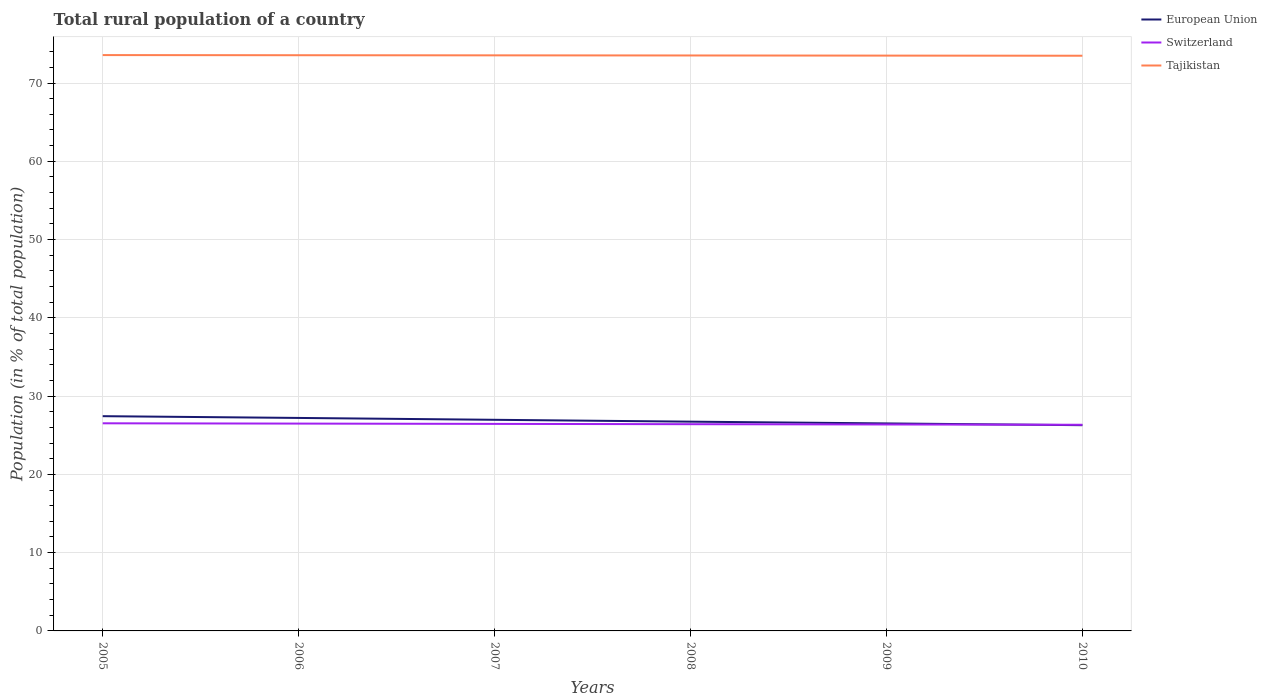How many different coloured lines are there?
Offer a terse response. 3. Does the line corresponding to Switzerland intersect with the line corresponding to Tajikistan?
Provide a short and direct response. No. Across all years, what is the maximum rural population in Switzerland?
Make the answer very short. 26.34. What is the total rural population in Tajikistan in the graph?
Your answer should be very brief. 0.02. What is the difference between the highest and the second highest rural population in Tajikistan?
Give a very brief answer. 0.08. Is the rural population in Tajikistan strictly greater than the rural population in European Union over the years?
Provide a succinct answer. No. How many lines are there?
Your answer should be compact. 3. How many years are there in the graph?
Keep it short and to the point. 6. What is the difference between two consecutive major ticks on the Y-axis?
Provide a succinct answer. 10. Does the graph contain any zero values?
Give a very brief answer. No. Does the graph contain grids?
Your answer should be very brief. Yes. What is the title of the graph?
Give a very brief answer. Total rural population of a country. What is the label or title of the X-axis?
Provide a succinct answer. Years. What is the label or title of the Y-axis?
Ensure brevity in your answer.  Population (in % of total population). What is the Population (in % of total population) in European Union in 2005?
Your answer should be compact. 27.43. What is the Population (in % of total population) in Switzerland in 2005?
Provide a short and direct response. 26.53. What is the Population (in % of total population) in Tajikistan in 2005?
Your response must be concise. 73.57. What is the Population (in % of total population) of European Union in 2006?
Keep it short and to the point. 27.21. What is the Population (in % of total population) in Switzerland in 2006?
Give a very brief answer. 26.49. What is the Population (in % of total population) of Tajikistan in 2006?
Provide a short and direct response. 73.55. What is the Population (in % of total population) of European Union in 2007?
Offer a very short reply. 26.97. What is the Population (in % of total population) of Switzerland in 2007?
Your answer should be very brief. 26.45. What is the Population (in % of total population) in Tajikistan in 2007?
Ensure brevity in your answer.  73.53. What is the Population (in % of total population) of European Union in 2008?
Your answer should be very brief. 26.74. What is the Population (in % of total population) in Switzerland in 2008?
Make the answer very short. 26.41. What is the Population (in % of total population) in Tajikistan in 2008?
Ensure brevity in your answer.  73.52. What is the Population (in % of total population) in European Union in 2009?
Offer a terse response. 26.51. What is the Population (in % of total population) in Switzerland in 2009?
Provide a succinct answer. 26.38. What is the Population (in % of total population) in Tajikistan in 2009?
Make the answer very short. 73.5. What is the Population (in % of total population) of European Union in 2010?
Offer a very short reply. 26.28. What is the Population (in % of total population) of Switzerland in 2010?
Provide a short and direct response. 26.34. What is the Population (in % of total population) of Tajikistan in 2010?
Make the answer very short. 73.48. Across all years, what is the maximum Population (in % of total population) of European Union?
Your answer should be very brief. 27.43. Across all years, what is the maximum Population (in % of total population) of Switzerland?
Keep it short and to the point. 26.53. Across all years, what is the maximum Population (in % of total population) of Tajikistan?
Provide a short and direct response. 73.57. Across all years, what is the minimum Population (in % of total population) in European Union?
Give a very brief answer. 26.28. Across all years, what is the minimum Population (in % of total population) of Switzerland?
Your response must be concise. 26.34. Across all years, what is the minimum Population (in % of total population) of Tajikistan?
Keep it short and to the point. 73.48. What is the total Population (in % of total population) in European Union in the graph?
Provide a succinct answer. 161.15. What is the total Population (in % of total population) in Switzerland in the graph?
Your answer should be very brief. 158.59. What is the total Population (in % of total population) of Tajikistan in the graph?
Keep it short and to the point. 441.15. What is the difference between the Population (in % of total population) of European Union in 2005 and that in 2006?
Your response must be concise. 0.22. What is the difference between the Population (in % of total population) of Switzerland in 2005 and that in 2006?
Offer a terse response. 0.04. What is the difference between the Population (in % of total population) of Tajikistan in 2005 and that in 2006?
Keep it short and to the point. 0.02. What is the difference between the Population (in % of total population) of European Union in 2005 and that in 2007?
Keep it short and to the point. 0.46. What is the difference between the Population (in % of total population) of Switzerland in 2005 and that in 2007?
Keep it short and to the point. 0.08. What is the difference between the Population (in % of total population) in Tajikistan in 2005 and that in 2007?
Provide a succinct answer. 0.03. What is the difference between the Population (in % of total population) of European Union in 2005 and that in 2008?
Offer a terse response. 0.7. What is the difference between the Population (in % of total population) of Switzerland in 2005 and that in 2008?
Your answer should be very brief. 0.11. What is the difference between the Population (in % of total population) in Tajikistan in 2005 and that in 2008?
Your response must be concise. 0.05. What is the difference between the Population (in % of total population) in European Union in 2005 and that in 2009?
Provide a succinct answer. 0.92. What is the difference between the Population (in % of total population) of Switzerland in 2005 and that in 2009?
Provide a succinct answer. 0.15. What is the difference between the Population (in % of total population) of Tajikistan in 2005 and that in 2009?
Your response must be concise. 0.07. What is the difference between the Population (in % of total population) in European Union in 2005 and that in 2010?
Keep it short and to the point. 1.15. What is the difference between the Population (in % of total population) in Switzerland in 2005 and that in 2010?
Offer a very short reply. 0.19. What is the difference between the Population (in % of total population) in Tajikistan in 2005 and that in 2010?
Your response must be concise. 0.08. What is the difference between the Population (in % of total population) of European Union in 2006 and that in 2007?
Provide a short and direct response. 0.24. What is the difference between the Population (in % of total population) in Switzerland in 2006 and that in 2007?
Provide a succinct answer. 0.04. What is the difference between the Population (in % of total population) in Tajikistan in 2006 and that in 2007?
Keep it short and to the point. 0.02. What is the difference between the Population (in % of total population) in European Union in 2006 and that in 2008?
Keep it short and to the point. 0.48. What is the difference between the Population (in % of total population) in Switzerland in 2006 and that in 2008?
Give a very brief answer. 0.08. What is the difference between the Population (in % of total population) in Tajikistan in 2006 and that in 2008?
Provide a short and direct response. 0.03. What is the difference between the Population (in % of total population) of European Union in 2006 and that in 2009?
Give a very brief answer. 0.7. What is the difference between the Population (in % of total population) of Switzerland in 2006 and that in 2009?
Give a very brief answer. 0.11. What is the difference between the Population (in % of total population) in European Union in 2006 and that in 2010?
Your response must be concise. 0.93. What is the difference between the Population (in % of total population) of Switzerland in 2006 and that in 2010?
Provide a succinct answer. 0.15. What is the difference between the Population (in % of total population) of Tajikistan in 2006 and that in 2010?
Offer a terse response. 0.07. What is the difference between the Population (in % of total population) in European Union in 2007 and that in 2008?
Ensure brevity in your answer.  0.24. What is the difference between the Population (in % of total population) in Switzerland in 2007 and that in 2008?
Offer a terse response. 0.04. What is the difference between the Population (in % of total population) of Tajikistan in 2007 and that in 2008?
Your answer should be very brief. 0.02. What is the difference between the Population (in % of total population) in European Union in 2007 and that in 2009?
Your answer should be compact. 0.46. What is the difference between the Population (in % of total population) of Switzerland in 2007 and that in 2009?
Make the answer very short. 0.07. What is the difference between the Population (in % of total population) in Tajikistan in 2007 and that in 2009?
Your answer should be compact. 0.03. What is the difference between the Population (in % of total population) of European Union in 2007 and that in 2010?
Make the answer very short. 0.69. What is the difference between the Population (in % of total population) of Switzerland in 2007 and that in 2010?
Offer a terse response. 0.11. What is the difference between the Population (in % of total population) in Tajikistan in 2007 and that in 2010?
Offer a very short reply. 0.05. What is the difference between the Population (in % of total population) in European Union in 2008 and that in 2009?
Provide a succinct answer. 0.23. What is the difference between the Population (in % of total population) of Switzerland in 2008 and that in 2009?
Make the answer very short. 0.04. What is the difference between the Population (in % of total population) of Tajikistan in 2008 and that in 2009?
Your answer should be very brief. 0.02. What is the difference between the Population (in % of total population) of European Union in 2008 and that in 2010?
Ensure brevity in your answer.  0.45. What is the difference between the Population (in % of total population) in Switzerland in 2008 and that in 2010?
Provide a succinct answer. 0.07. What is the difference between the Population (in % of total population) of Tajikistan in 2008 and that in 2010?
Ensure brevity in your answer.  0.03. What is the difference between the Population (in % of total population) in European Union in 2009 and that in 2010?
Make the answer very short. 0.23. What is the difference between the Population (in % of total population) in Switzerland in 2009 and that in 2010?
Keep it short and to the point. 0.04. What is the difference between the Population (in % of total population) of Tajikistan in 2009 and that in 2010?
Provide a short and direct response. 0.02. What is the difference between the Population (in % of total population) in European Union in 2005 and the Population (in % of total population) in Switzerland in 2006?
Offer a terse response. 0.95. What is the difference between the Population (in % of total population) of European Union in 2005 and the Population (in % of total population) of Tajikistan in 2006?
Your answer should be compact. -46.12. What is the difference between the Population (in % of total population) in Switzerland in 2005 and the Population (in % of total population) in Tajikistan in 2006?
Your response must be concise. -47.02. What is the difference between the Population (in % of total population) of European Union in 2005 and the Population (in % of total population) of Tajikistan in 2007?
Ensure brevity in your answer.  -46.1. What is the difference between the Population (in % of total population) in Switzerland in 2005 and the Population (in % of total population) in Tajikistan in 2007?
Provide a succinct answer. -47.01. What is the difference between the Population (in % of total population) of European Union in 2005 and the Population (in % of total population) of Switzerland in 2008?
Give a very brief answer. 1.02. What is the difference between the Population (in % of total population) in European Union in 2005 and the Population (in % of total population) in Tajikistan in 2008?
Your answer should be very brief. -46.08. What is the difference between the Population (in % of total population) in Switzerland in 2005 and the Population (in % of total population) in Tajikistan in 2008?
Offer a terse response. -46.99. What is the difference between the Population (in % of total population) of European Union in 2005 and the Population (in % of total population) of Switzerland in 2009?
Your answer should be very brief. 1.06. What is the difference between the Population (in % of total population) in European Union in 2005 and the Population (in % of total population) in Tajikistan in 2009?
Make the answer very short. -46.07. What is the difference between the Population (in % of total population) in Switzerland in 2005 and the Population (in % of total population) in Tajikistan in 2009?
Offer a terse response. -46.97. What is the difference between the Population (in % of total population) of European Union in 2005 and the Population (in % of total population) of Switzerland in 2010?
Make the answer very short. 1.1. What is the difference between the Population (in % of total population) of European Union in 2005 and the Population (in % of total population) of Tajikistan in 2010?
Your answer should be compact. -46.05. What is the difference between the Population (in % of total population) of Switzerland in 2005 and the Population (in % of total population) of Tajikistan in 2010?
Your answer should be very brief. -46.96. What is the difference between the Population (in % of total population) in European Union in 2006 and the Population (in % of total population) in Switzerland in 2007?
Ensure brevity in your answer.  0.76. What is the difference between the Population (in % of total population) in European Union in 2006 and the Population (in % of total population) in Tajikistan in 2007?
Provide a succinct answer. -46.32. What is the difference between the Population (in % of total population) of Switzerland in 2006 and the Population (in % of total population) of Tajikistan in 2007?
Your answer should be compact. -47.05. What is the difference between the Population (in % of total population) of European Union in 2006 and the Population (in % of total population) of Switzerland in 2008?
Give a very brief answer. 0.8. What is the difference between the Population (in % of total population) in European Union in 2006 and the Population (in % of total population) in Tajikistan in 2008?
Provide a succinct answer. -46.31. What is the difference between the Population (in % of total population) in Switzerland in 2006 and the Population (in % of total population) in Tajikistan in 2008?
Your response must be concise. -47.03. What is the difference between the Population (in % of total population) in European Union in 2006 and the Population (in % of total population) in Switzerland in 2009?
Your answer should be very brief. 0.84. What is the difference between the Population (in % of total population) in European Union in 2006 and the Population (in % of total population) in Tajikistan in 2009?
Keep it short and to the point. -46.29. What is the difference between the Population (in % of total population) in Switzerland in 2006 and the Population (in % of total population) in Tajikistan in 2009?
Ensure brevity in your answer.  -47.01. What is the difference between the Population (in % of total population) of European Union in 2006 and the Population (in % of total population) of Switzerland in 2010?
Give a very brief answer. 0.87. What is the difference between the Population (in % of total population) in European Union in 2006 and the Population (in % of total population) in Tajikistan in 2010?
Provide a succinct answer. -46.27. What is the difference between the Population (in % of total population) in Switzerland in 2006 and the Population (in % of total population) in Tajikistan in 2010?
Keep it short and to the point. -47. What is the difference between the Population (in % of total population) of European Union in 2007 and the Population (in % of total population) of Switzerland in 2008?
Your answer should be very brief. 0.56. What is the difference between the Population (in % of total population) of European Union in 2007 and the Population (in % of total population) of Tajikistan in 2008?
Give a very brief answer. -46.54. What is the difference between the Population (in % of total population) in Switzerland in 2007 and the Population (in % of total population) in Tajikistan in 2008?
Ensure brevity in your answer.  -47.07. What is the difference between the Population (in % of total population) in European Union in 2007 and the Population (in % of total population) in Switzerland in 2009?
Provide a short and direct response. 0.6. What is the difference between the Population (in % of total population) in European Union in 2007 and the Population (in % of total population) in Tajikistan in 2009?
Keep it short and to the point. -46.53. What is the difference between the Population (in % of total population) in Switzerland in 2007 and the Population (in % of total population) in Tajikistan in 2009?
Offer a terse response. -47.05. What is the difference between the Population (in % of total population) of European Union in 2007 and the Population (in % of total population) of Switzerland in 2010?
Your answer should be very brief. 0.64. What is the difference between the Population (in % of total population) in European Union in 2007 and the Population (in % of total population) in Tajikistan in 2010?
Provide a short and direct response. -46.51. What is the difference between the Population (in % of total population) in Switzerland in 2007 and the Population (in % of total population) in Tajikistan in 2010?
Your answer should be compact. -47.03. What is the difference between the Population (in % of total population) in European Union in 2008 and the Population (in % of total population) in Switzerland in 2009?
Offer a very short reply. 0.36. What is the difference between the Population (in % of total population) in European Union in 2008 and the Population (in % of total population) in Tajikistan in 2009?
Ensure brevity in your answer.  -46.76. What is the difference between the Population (in % of total population) in Switzerland in 2008 and the Population (in % of total population) in Tajikistan in 2009?
Your answer should be compact. -47.09. What is the difference between the Population (in % of total population) of European Union in 2008 and the Population (in % of total population) of Switzerland in 2010?
Keep it short and to the point. 0.4. What is the difference between the Population (in % of total population) of European Union in 2008 and the Population (in % of total population) of Tajikistan in 2010?
Ensure brevity in your answer.  -46.75. What is the difference between the Population (in % of total population) of Switzerland in 2008 and the Population (in % of total population) of Tajikistan in 2010?
Make the answer very short. -47.07. What is the difference between the Population (in % of total population) in European Union in 2009 and the Population (in % of total population) in Switzerland in 2010?
Give a very brief answer. 0.17. What is the difference between the Population (in % of total population) in European Union in 2009 and the Population (in % of total population) in Tajikistan in 2010?
Offer a very short reply. -46.97. What is the difference between the Population (in % of total population) in Switzerland in 2009 and the Population (in % of total population) in Tajikistan in 2010?
Make the answer very short. -47.11. What is the average Population (in % of total population) of European Union per year?
Provide a succinct answer. 26.86. What is the average Population (in % of total population) in Switzerland per year?
Make the answer very short. 26.43. What is the average Population (in % of total population) of Tajikistan per year?
Offer a terse response. 73.53. In the year 2005, what is the difference between the Population (in % of total population) in European Union and Population (in % of total population) in Switzerland?
Provide a short and direct response. 0.91. In the year 2005, what is the difference between the Population (in % of total population) in European Union and Population (in % of total population) in Tajikistan?
Provide a short and direct response. -46.13. In the year 2005, what is the difference between the Population (in % of total population) in Switzerland and Population (in % of total population) in Tajikistan?
Your answer should be very brief. -47.04. In the year 2006, what is the difference between the Population (in % of total population) of European Union and Population (in % of total population) of Switzerland?
Keep it short and to the point. 0.72. In the year 2006, what is the difference between the Population (in % of total population) of European Union and Population (in % of total population) of Tajikistan?
Offer a terse response. -46.34. In the year 2006, what is the difference between the Population (in % of total population) in Switzerland and Population (in % of total population) in Tajikistan?
Offer a terse response. -47.06. In the year 2007, what is the difference between the Population (in % of total population) in European Union and Population (in % of total population) in Switzerland?
Your answer should be compact. 0.52. In the year 2007, what is the difference between the Population (in % of total population) of European Union and Population (in % of total population) of Tajikistan?
Give a very brief answer. -46.56. In the year 2007, what is the difference between the Population (in % of total population) in Switzerland and Population (in % of total population) in Tajikistan?
Your response must be concise. -47.08. In the year 2008, what is the difference between the Population (in % of total population) of European Union and Population (in % of total population) of Switzerland?
Ensure brevity in your answer.  0.32. In the year 2008, what is the difference between the Population (in % of total population) in European Union and Population (in % of total population) in Tajikistan?
Offer a very short reply. -46.78. In the year 2008, what is the difference between the Population (in % of total population) in Switzerland and Population (in % of total population) in Tajikistan?
Provide a short and direct response. -47.1. In the year 2009, what is the difference between the Population (in % of total population) in European Union and Population (in % of total population) in Switzerland?
Give a very brief answer. 0.13. In the year 2009, what is the difference between the Population (in % of total population) of European Union and Population (in % of total population) of Tajikistan?
Ensure brevity in your answer.  -46.99. In the year 2009, what is the difference between the Population (in % of total population) of Switzerland and Population (in % of total population) of Tajikistan?
Provide a succinct answer. -47.12. In the year 2010, what is the difference between the Population (in % of total population) of European Union and Population (in % of total population) of Switzerland?
Offer a terse response. -0.05. In the year 2010, what is the difference between the Population (in % of total population) in European Union and Population (in % of total population) in Tajikistan?
Your answer should be very brief. -47.2. In the year 2010, what is the difference between the Population (in % of total population) in Switzerland and Population (in % of total population) in Tajikistan?
Offer a terse response. -47.15. What is the ratio of the Population (in % of total population) of European Union in 2005 to that in 2006?
Your answer should be compact. 1.01. What is the ratio of the Population (in % of total population) of Switzerland in 2005 to that in 2006?
Your response must be concise. 1. What is the ratio of the Population (in % of total population) in Tajikistan in 2005 to that in 2006?
Your answer should be very brief. 1. What is the ratio of the Population (in % of total population) in European Union in 2005 to that in 2007?
Your answer should be very brief. 1.02. What is the ratio of the Population (in % of total population) of Switzerland in 2005 to that in 2007?
Your answer should be compact. 1. What is the ratio of the Population (in % of total population) of Tajikistan in 2005 to that in 2007?
Your answer should be compact. 1. What is the ratio of the Population (in % of total population) of European Union in 2005 to that in 2008?
Offer a terse response. 1.03. What is the ratio of the Population (in % of total population) in Tajikistan in 2005 to that in 2008?
Your answer should be compact. 1. What is the ratio of the Population (in % of total population) of European Union in 2005 to that in 2009?
Keep it short and to the point. 1.03. What is the ratio of the Population (in % of total population) of European Union in 2005 to that in 2010?
Give a very brief answer. 1.04. What is the ratio of the Population (in % of total population) of Switzerland in 2005 to that in 2010?
Your answer should be very brief. 1.01. What is the ratio of the Population (in % of total population) of Tajikistan in 2005 to that in 2010?
Your response must be concise. 1. What is the ratio of the Population (in % of total population) in European Union in 2006 to that in 2007?
Provide a succinct answer. 1.01. What is the ratio of the Population (in % of total population) of Switzerland in 2006 to that in 2007?
Your answer should be very brief. 1. What is the ratio of the Population (in % of total population) in European Union in 2006 to that in 2008?
Make the answer very short. 1.02. What is the ratio of the Population (in % of total population) of Switzerland in 2006 to that in 2008?
Ensure brevity in your answer.  1. What is the ratio of the Population (in % of total population) in Tajikistan in 2006 to that in 2008?
Ensure brevity in your answer.  1. What is the ratio of the Population (in % of total population) of European Union in 2006 to that in 2009?
Your answer should be compact. 1.03. What is the ratio of the Population (in % of total population) in Switzerland in 2006 to that in 2009?
Your answer should be very brief. 1. What is the ratio of the Population (in % of total population) in Tajikistan in 2006 to that in 2009?
Provide a short and direct response. 1. What is the ratio of the Population (in % of total population) in European Union in 2006 to that in 2010?
Ensure brevity in your answer.  1.04. What is the ratio of the Population (in % of total population) of European Union in 2007 to that in 2008?
Offer a very short reply. 1.01. What is the ratio of the Population (in % of total population) of Tajikistan in 2007 to that in 2008?
Provide a succinct answer. 1. What is the ratio of the Population (in % of total population) of European Union in 2007 to that in 2009?
Provide a succinct answer. 1.02. What is the ratio of the Population (in % of total population) of Tajikistan in 2007 to that in 2009?
Ensure brevity in your answer.  1. What is the ratio of the Population (in % of total population) in European Union in 2007 to that in 2010?
Give a very brief answer. 1.03. What is the ratio of the Population (in % of total population) of Switzerland in 2007 to that in 2010?
Offer a terse response. 1. What is the ratio of the Population (in % of total population) in European Union in 2008 to that in 2009?
Offer a very short reply. 1.01. What is the ratio of the Population (in % of total population) of Tajikistan in 2008 to that in 2009?
Keep it short and to the point. 1. What is the ratio of the Population (in % of total population) in European Union in 2008 to that in 2010?
Your response must be concise. 1.02. What is the ratio of the Population (in % of total population) in Switzerland in 2008 to that in 2010?
Give a very brief answer. 1. What is the ratio of the Population (in % of total population) of Tajikistan in 2008 to that in 2010?
Your answer should be compact. 1. What is the ratio of the Population (in % of total population) of European Union in 2009 to that in 2010?
Your response must be concise. 1.01. What is the difference between the highest and the second highest Population (in % of total population) in European Union?
Provide a short and direct response. 0.22. What is the difference between the highest and the second highest Population (in % of total population) in Switzerland?
Provide a succinct answer. 0.04. What is the difference between the highest and the second highest Population (in % of total population) of Tajikistan?
Ensure brevity in your answer.  0.02. What is the difference between the highest and the lowest Population (in % of total population) of European Union?
Make the answer very short. 1.15. What is the difference between the highest and the lowest Population (in % of total population) in Switzerland?
Provide a succinct answer. 0.19. What is the difference between the highest and the lowest Population (in % of total population) of Tajikistan?
Offer a very short reply. 0.08. 